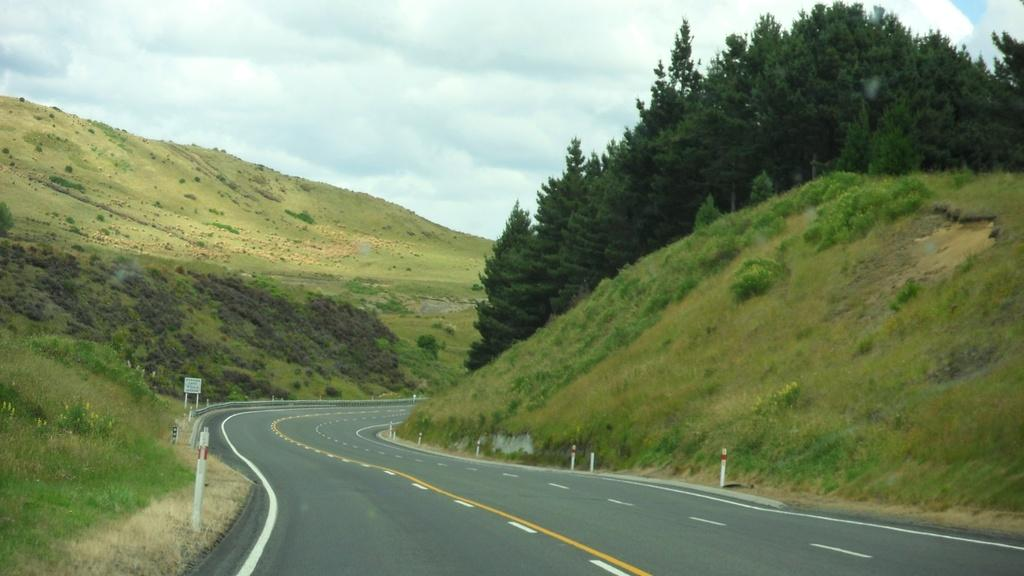What is the main feature in the middle of the image? There is a highway in the middle of the image. What can be seen on either side of the highway? There are hills on either side of the highway. What type of vegetation is present on the hills? Trees are present on the hills. What is visible at the top of the image? The sky is visible at the top of the image. What type of leather can be seen covering the pin on the side of the highway? There is no pin or leather present in the image; it features a highway with hills and trees. 